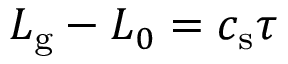<formula> <loc_0><loc_0><loc_500><loc_500>L _ { g } - L _ { 0 } = c _ { s } \tau</formula> 